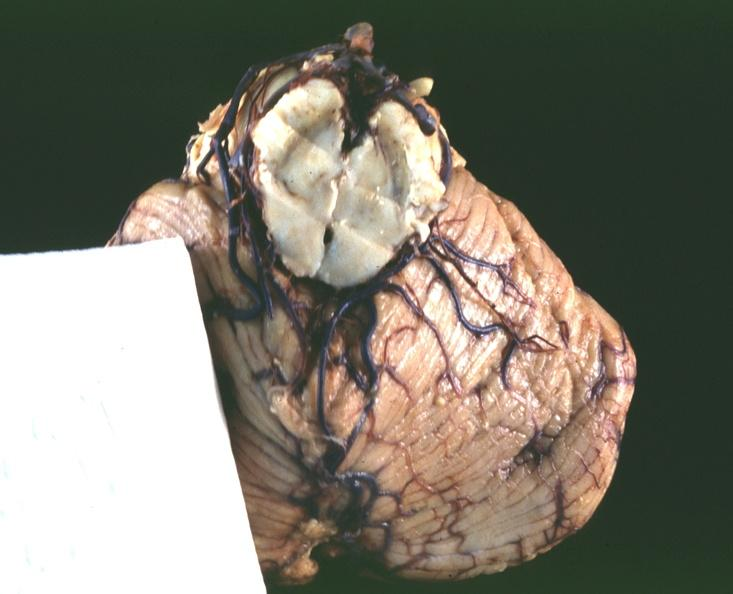s nervous present?
Answer the question using a single word or phrase. Yes 